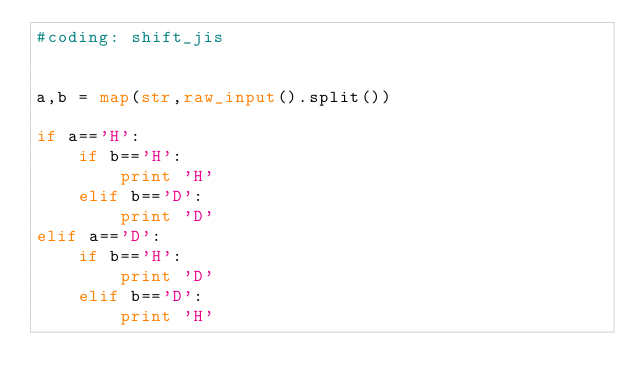Convert code to text. <code><loc_0><loc_0><loc_500><loc_500><_Python_>#coding: shift_jis


a,b = map(str,raw_input().split())

if a=='H':
    if b=='H':
        print 'H'
    elif b=='D':
        print 'D'
elif a=='D':
    if b=='H':
        print 'D'
    elif b=='D':
        print 'H'</code> 